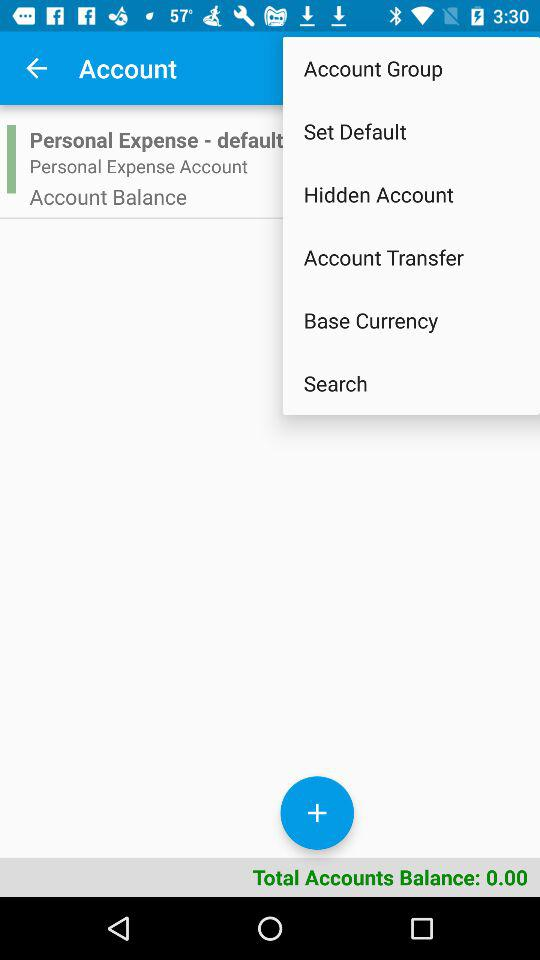How many account groups are there?
Answer the question using a single word or phrase. 1 